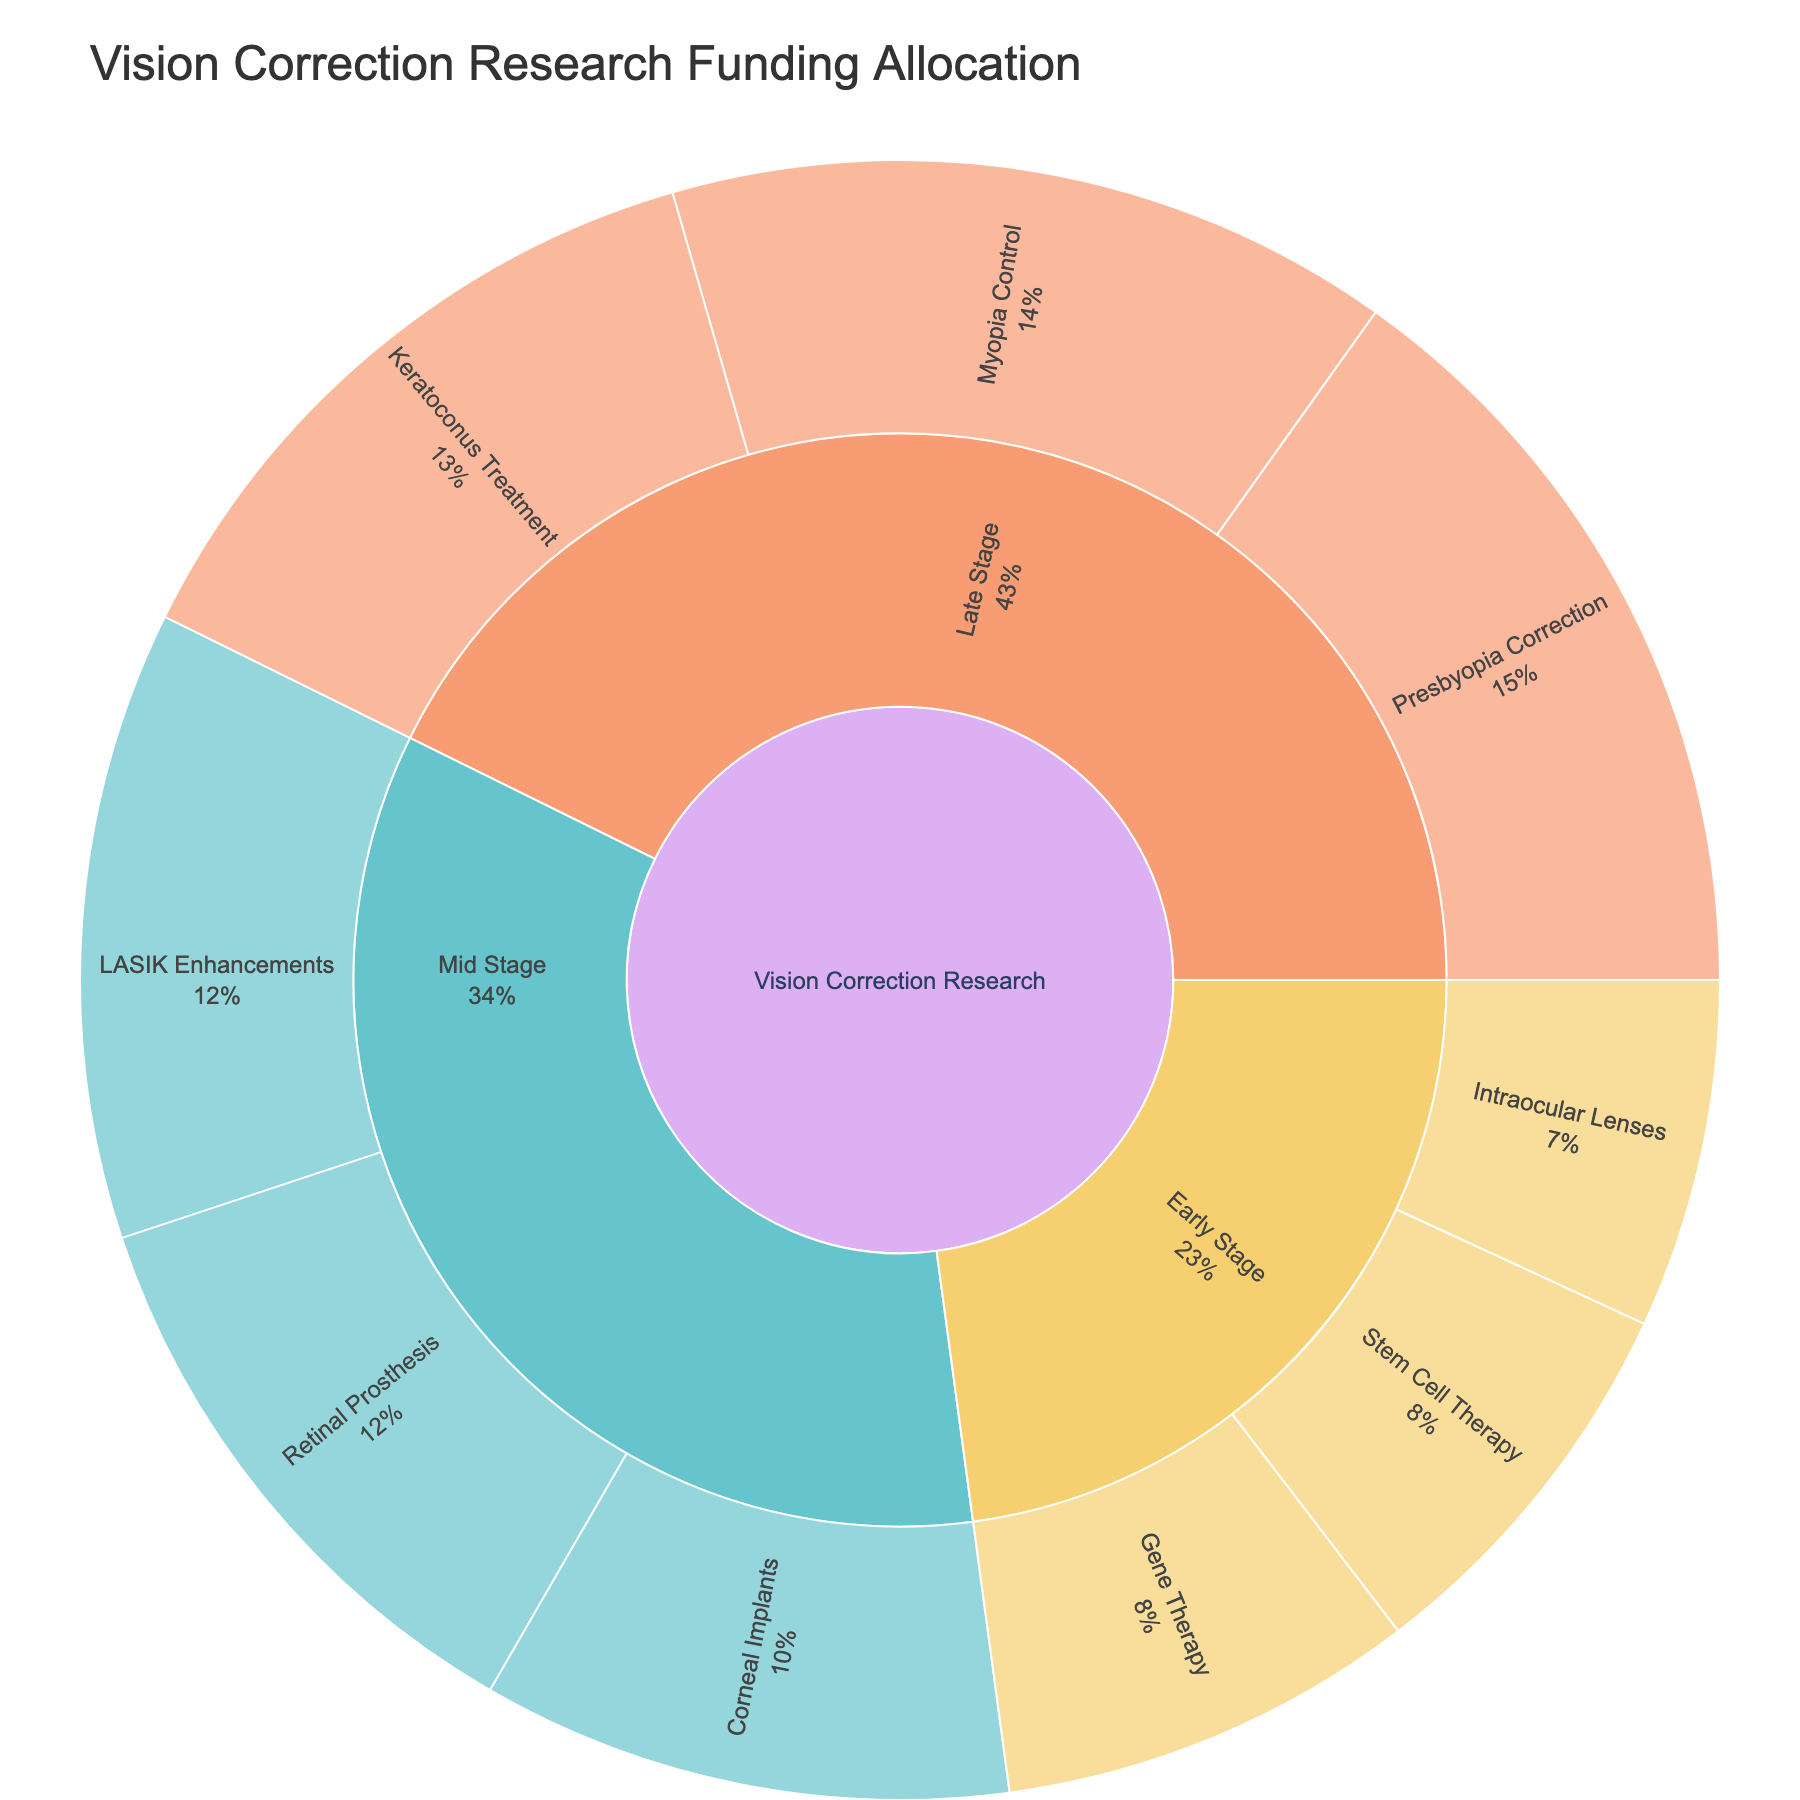What's the title of the figure? The title is typically found at the top of the figure. In this case, it states the main theme or focus of the figure.
Answer: Vision Correction Research Funding Allocation Which technology in the Early Stage category has the highest funding? Locate the Early Stage subcategory within the Sunburst Plot and identify the technology segment with the largest arc.
Answer: Gene Therapy What is the total funding allocated to Mid Stage projects? Add the funding amounts for all technologies in the Mid Stage category: LASIK Enhancements ($4,500,000), Corneal Implants ($3,800,000), and Retinal Prosthesis ($4,200,000).
Answer: $12,500,000 How does the funding for Retinal Prosthesis compare to Corneal Implants? Compare the funding values of Retinal Prosthesis and Corneal Implants directly from the plot's labels.
Answer: Retinal Prosthesis has higher funding Which category has more funding: Early Stage or Late Stage? Sum the funding for each stage. Early Stage: Intraocular Lenses ($2,500,000) + Gene Therapy ($3,000,000) + Stem Cell Therapy ($2,800,000) = $8,300,000. Late Stage: Presbyopia Correction ($5,500,000) + Keratoconus Treatment ($4,800,000) + Myopia Control ($5,200,000) = $15,500,000.
Answer: Late Stage What's the percentage of total funding allocated to Myopia Control? Determine the total funding by summing all values. Total: $45,800,000. Then divide the Myopia Control funding by the total and convert it to a percentage: ($5,200,000 / $45,800,000) * 100.
Answer: 11.35% How does the funding allocation for Stem Cell Therapy in Early Stage compare to the funding for Keratoconus Treatment in Late Stage? Compare the specific funding amounts: Stem Cell Therapy ($2,800,000) and Keratoconus Treatment ($4,800,000).
Answer: Keratoconus Treatment has more funding What is the overall funding difference between the highest and lowest funded technologies across all stages? Identify the highest (Presbyopia Correction $5,500,000) and the lowest (Intraocular Lenses $2,500,000) funded technologies and find the difference: $5,500,000 - $2,500,000.
Answer: $3,000,000 Which development stage has the highest funding for vision correction research? Compare the total funding across Early Stage, Mid Stage, and Late Stage categories and identify the highest.
Answer: Late Stage Which technology in Mid Stage has the smallest funding allocation? From the Mid Stage subcategory, identify the technology with the smallest arc, which represents the smallest funding.
Answer: Corneal Implants 